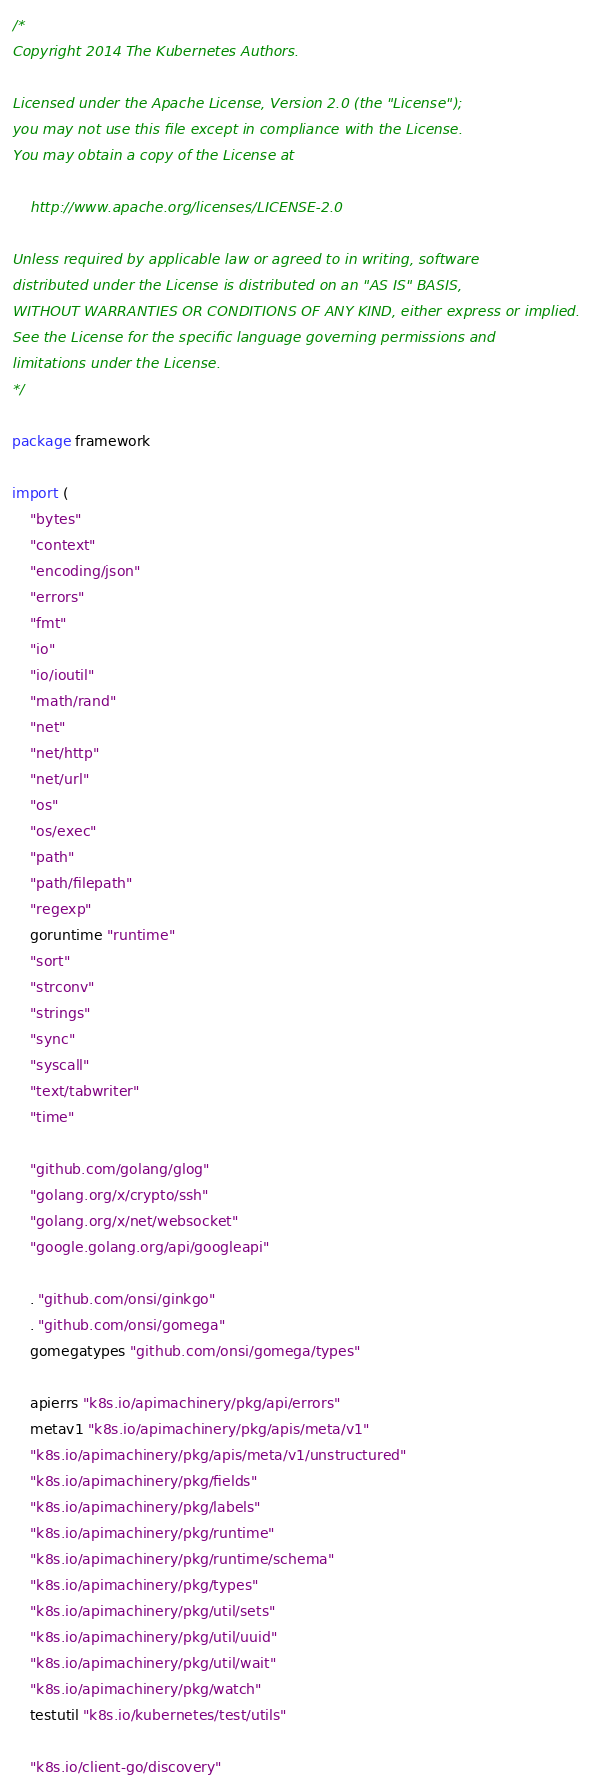<code> <loc_0><loc_0><loc_500><loc_500><_Go_>/*
Copyright 2014 The Kubernetes Authors.

Licensed under the Apache License, Version 2.0 (the "License");
you may not use this file except in compliance with the License.
You may obtain a copy of the License at

    http://www.apache.org/licenses/LICENSE-2.0

Unless required by applicable law or agreed to in writing, software
distributed under the License is distributed on an "AS IS" BASIS,
WITHOUT WARRANTIES OR CONDITIONS OF ANY KIND, either express or implied.
See the License for the specific language governing permissions and
limitations under the License.
*/

package framework

import (
	"bytes"
	"context"
	"encoding/json"
	"errors"
	"fmt"
	"io"
	"io/ioutil"
	"math/rand"
	"net"
	"net/http"
	"net/url"
	"os"
	"os/exec"
	"path"
	"path/filepath"
	"regexp"
	goruntime "runtime"
	"sort"
	"strconv"
	"strings"
	"sync"
	"syscall"
	"text/tabwriter"
	"time"

	"github.com/golang/glog"
	"golang.org/x/crypto/ssh"
	"golang.org/x/net/websocket"
	"google.golang.org/api/googleapi"

	. "github.com/onsi/ginkgo"
	. "github.com/onsi/gomega"
	gomegatypes "github.com/onsi/gomega/types"

	apierrs "k8s.io/apimachinery/pkg/api/errors"
	metav1 "k8s.io/apimachinery/pkg/apis/meta/v1"
	"k8s.io/apimachinery/pkg/apis/meta/v1/unstructured"
	"k8s.io/apimachinery/pkg/fields"
	"k8s.io/apimachinery/pkg/labels"
	"k8s.io/apimachinery/pkg/runtime"
	"k8s.io/apimachinery/pkg/runtime/schema"
	"k8s.io/apimachinery/pkg/types"
	"k8s.io/apimachinery/pkg/util/sets"
	"k8s.io/apimachinery/pkg/util/uuid"
	"k8s.io/apimachinery/pkg/util/wait"
	"k8s.io/apimachinery/pkg/watch"
	testutil "k8s.io/kubernetes/test/utils"

	"k8s.io/client-go/discovery"</code> 